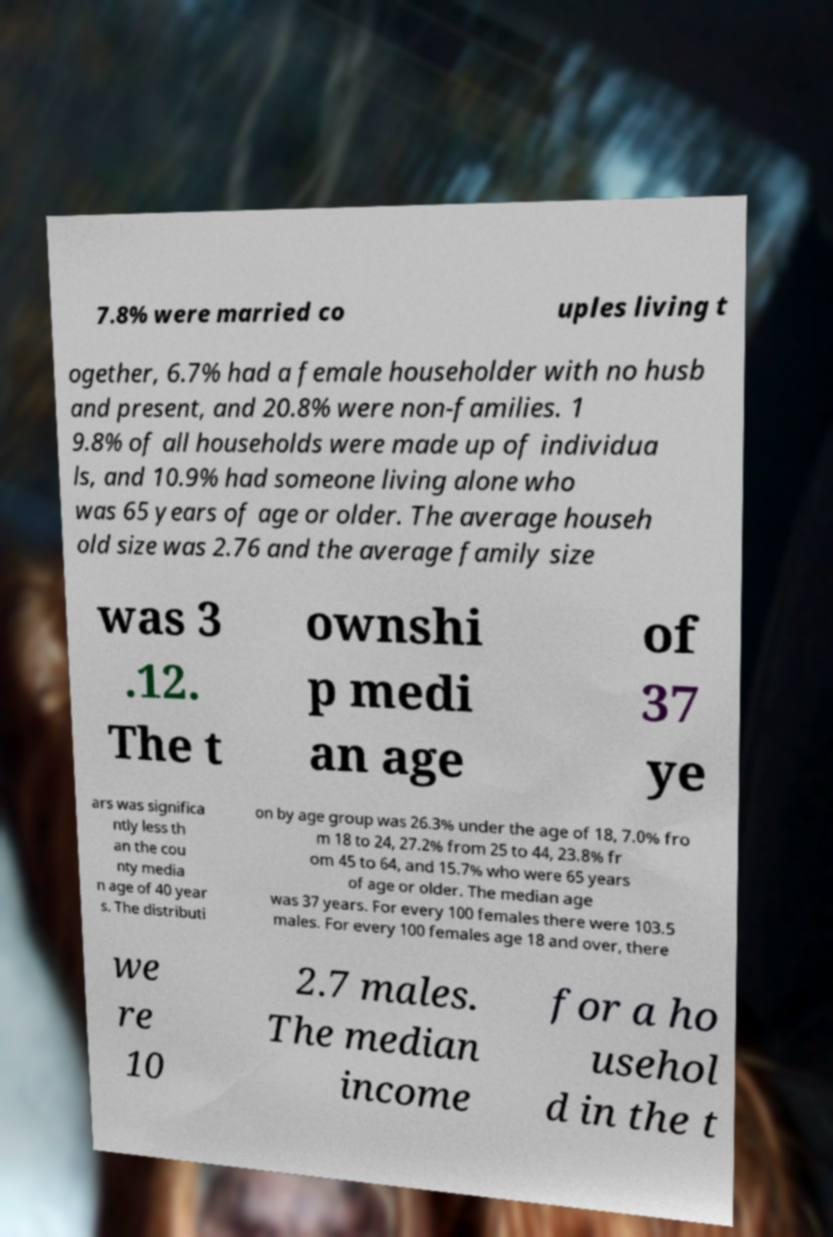Can you accurately transcribe the text from the provided image for me? 7.8% were married co uples living t ogether, 6.7% had a female householder with no husb and present, and 20.8% were non-families. 1 9.8% of all households were made up of individua ls, and 10.9% had someone living alone who was 65 years of age or older. The average househ old size was 2.76 and the average family size was 3 .12. The t ownshi p medi an age of 37 ye ars was significa ntly less th an the cou nty media n age of 40 year s. The distributi on by age group was 26.3% under the age of 18, 7.0% fro m 18 to 24, 27.2% from 25 to 44, 23.8% fr om 45 to 64, and 15.7% who were 65 years of age or older. The median age was 37 years. For every 100 females there were 103.5 males. For every 100 females age 18 and over, there we re 10 2.7 males. The median income for a ho usehol d in the t 